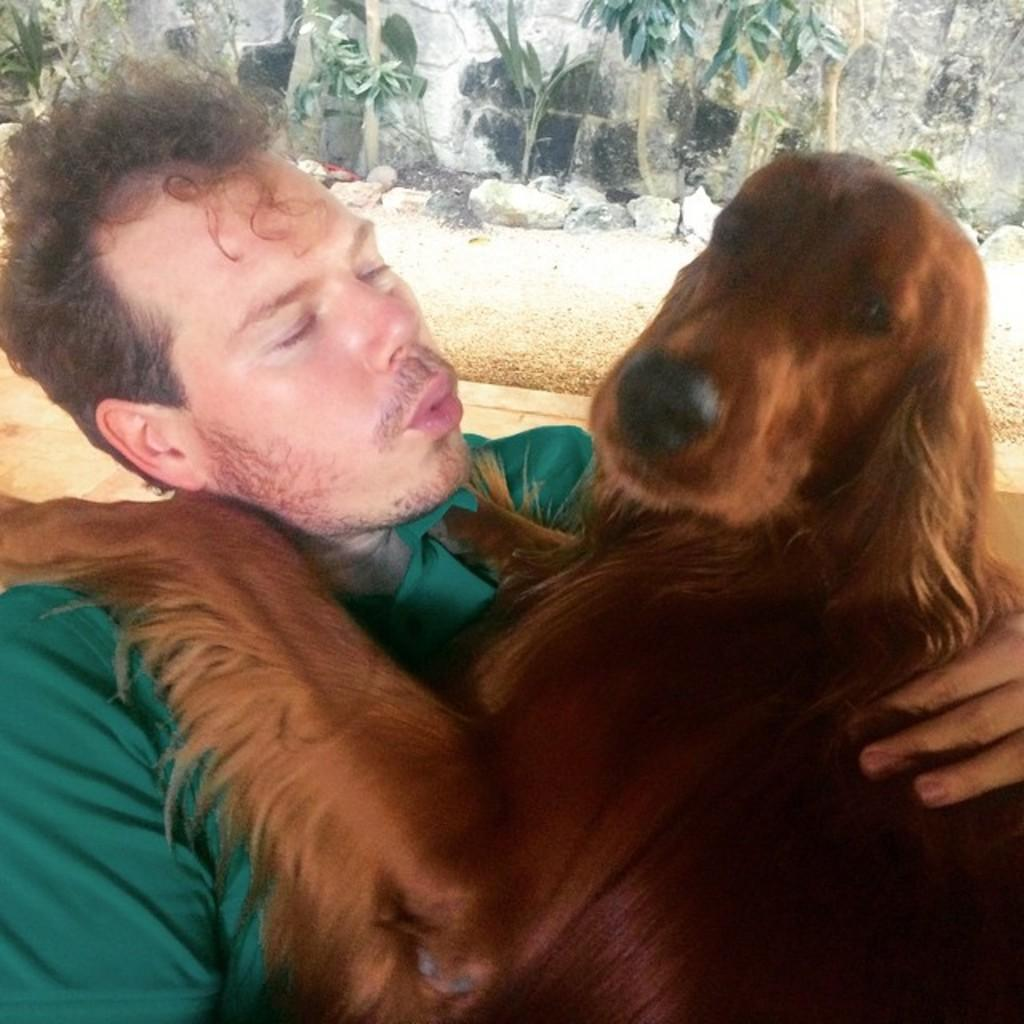Who is present in the image? There is a person in the image. What is the person holding? The person is holding a dog. What is the person wearing? The person is wearing a green shirt. What is the weather like in the image? The background of the image is sunny. What type of vegetation can be seen in the background? There are trees visible in the background. What type of fuel is being used by the dog in the image? There is no mention of fuel in the image, and the dog is not shown using any fuel. 